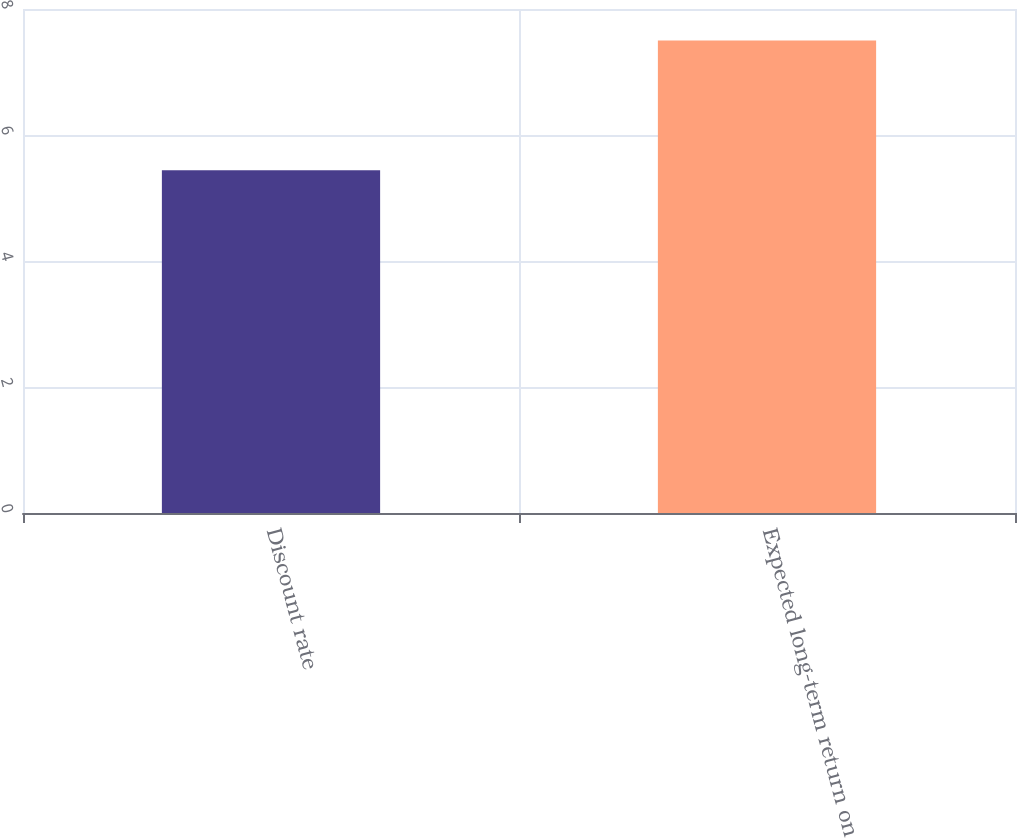Convert chart. <chart><loc_0><loc_0><loc_500><loc_500><bar_chart><fcel>Discount rate<fcel>Expected long-term return on<nl><fcel>5.44<fcel>7.5<nl></chart> 